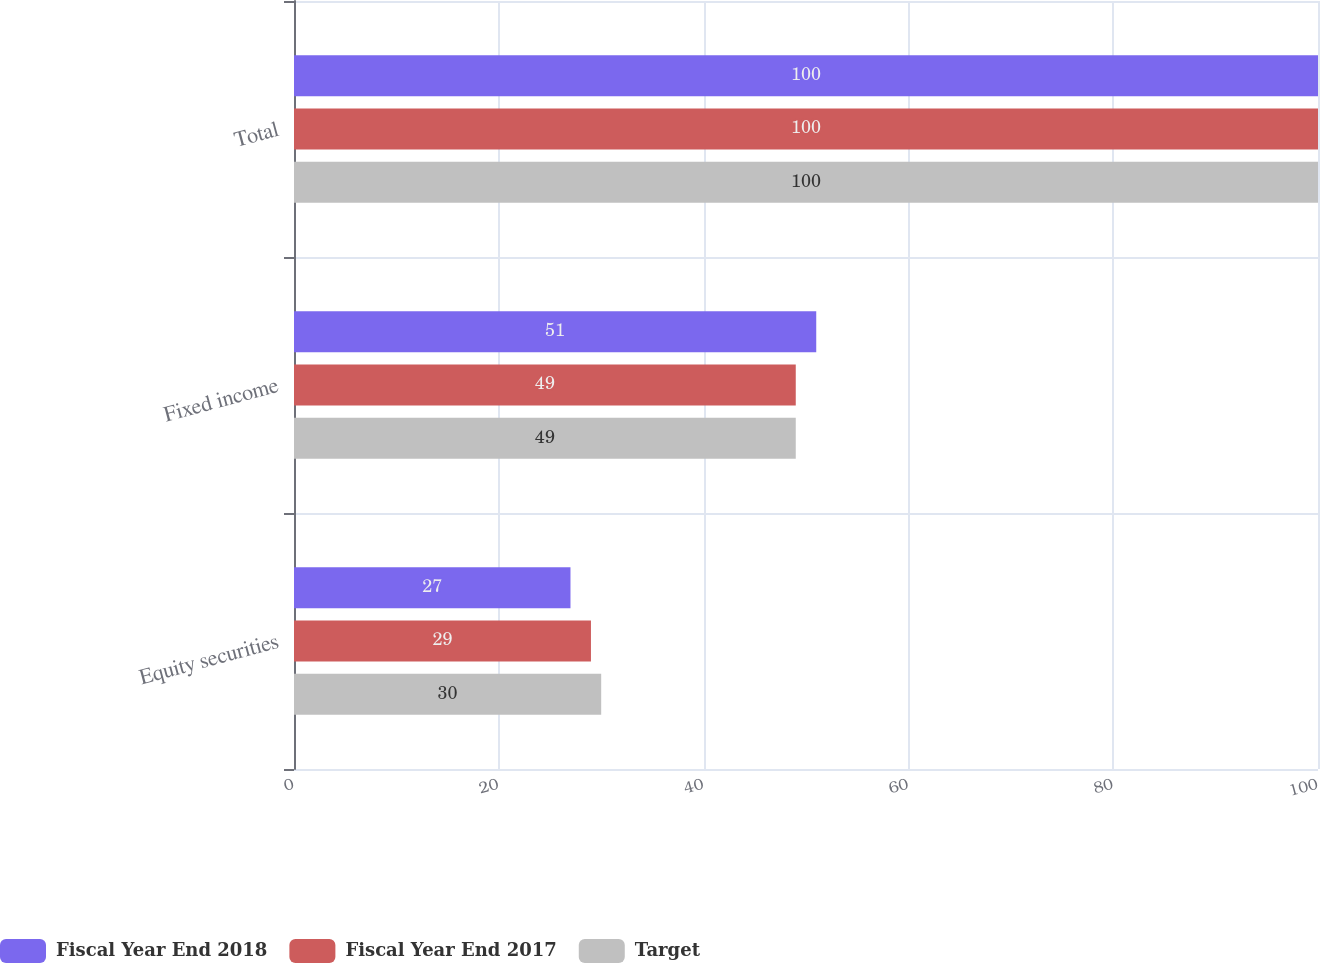<chart> <loc_0><loc_0><loc_500><loc_500><stacked_bar_chart><ecel><fcel>Equity securities<fcel>Fixed income<fcel>Total<nl><fcel>Fiscal Year End 2018<fcel>27<fcel>51<fcel>100<nl><fcel>Fiscal Year End 2017<fcel>29<fcel>49<fcel>100<nl><fcel>Target<fcel>30<fcel>49<fcel>100<nl></chart> 